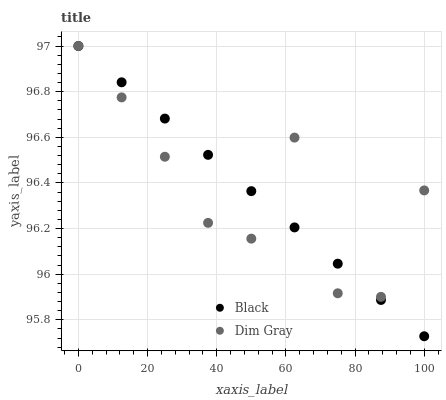Does Dim Gray have the minimum area under the curve?
Answer yes or no. Yes. Does Black have the maximum area under the curve?
Answer yes or no. Yes. Does Black have the minimum area under the curve?
Answer yes or no. No. Is Black the smoothest?
Answer yes or no. Yes. Is Dim Gray the roughest?
Answer yes or no. Yes. Is Black the roughest?
Answer yes or no. No. Does Black have the lowest value?
Answer yes or no. Yes. Does Black have the highest value?
Answer yes or no. Yes. Does Dim Gray intersect Black?
Answer yes or no. Yes. Is Dim Gray less than Black?
Answer yes or no. No. Is Dim Gray greater than Black?
Answer yes or no. No. 